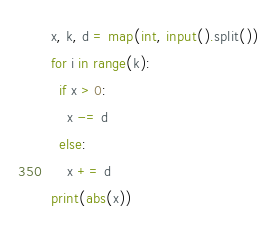Convert code to text. <code><loc_0><loc_0><loc_500><loc_500><_Python_>x, k, d = map(int, input().split())
for i in range(k):
  if x > 0:
    x -= d
  else:
    x += d
print(abs(x))</code> 